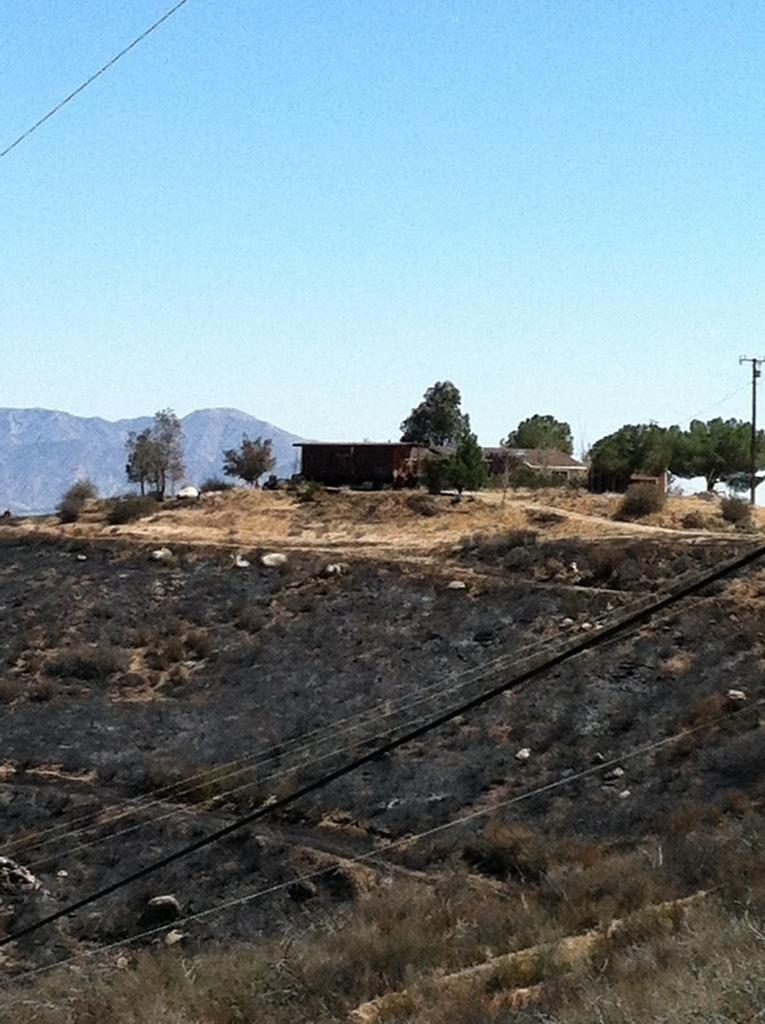What type of ground surface is visible in the image? There is grass on the ground in the image. What else can be seen in the image besides the grass? There are wires visible in the image. What is the color of the house in the image? The house in the image is brown-colored. What can be seen in the background of the image? There are trees, hills, and the sky visible in the background of the image. What type of fork is used to eat the history depicted in the image? There is no fork or history present in the image; it features grass, wires, a brown-colored house, trees, hills, and the sky. 